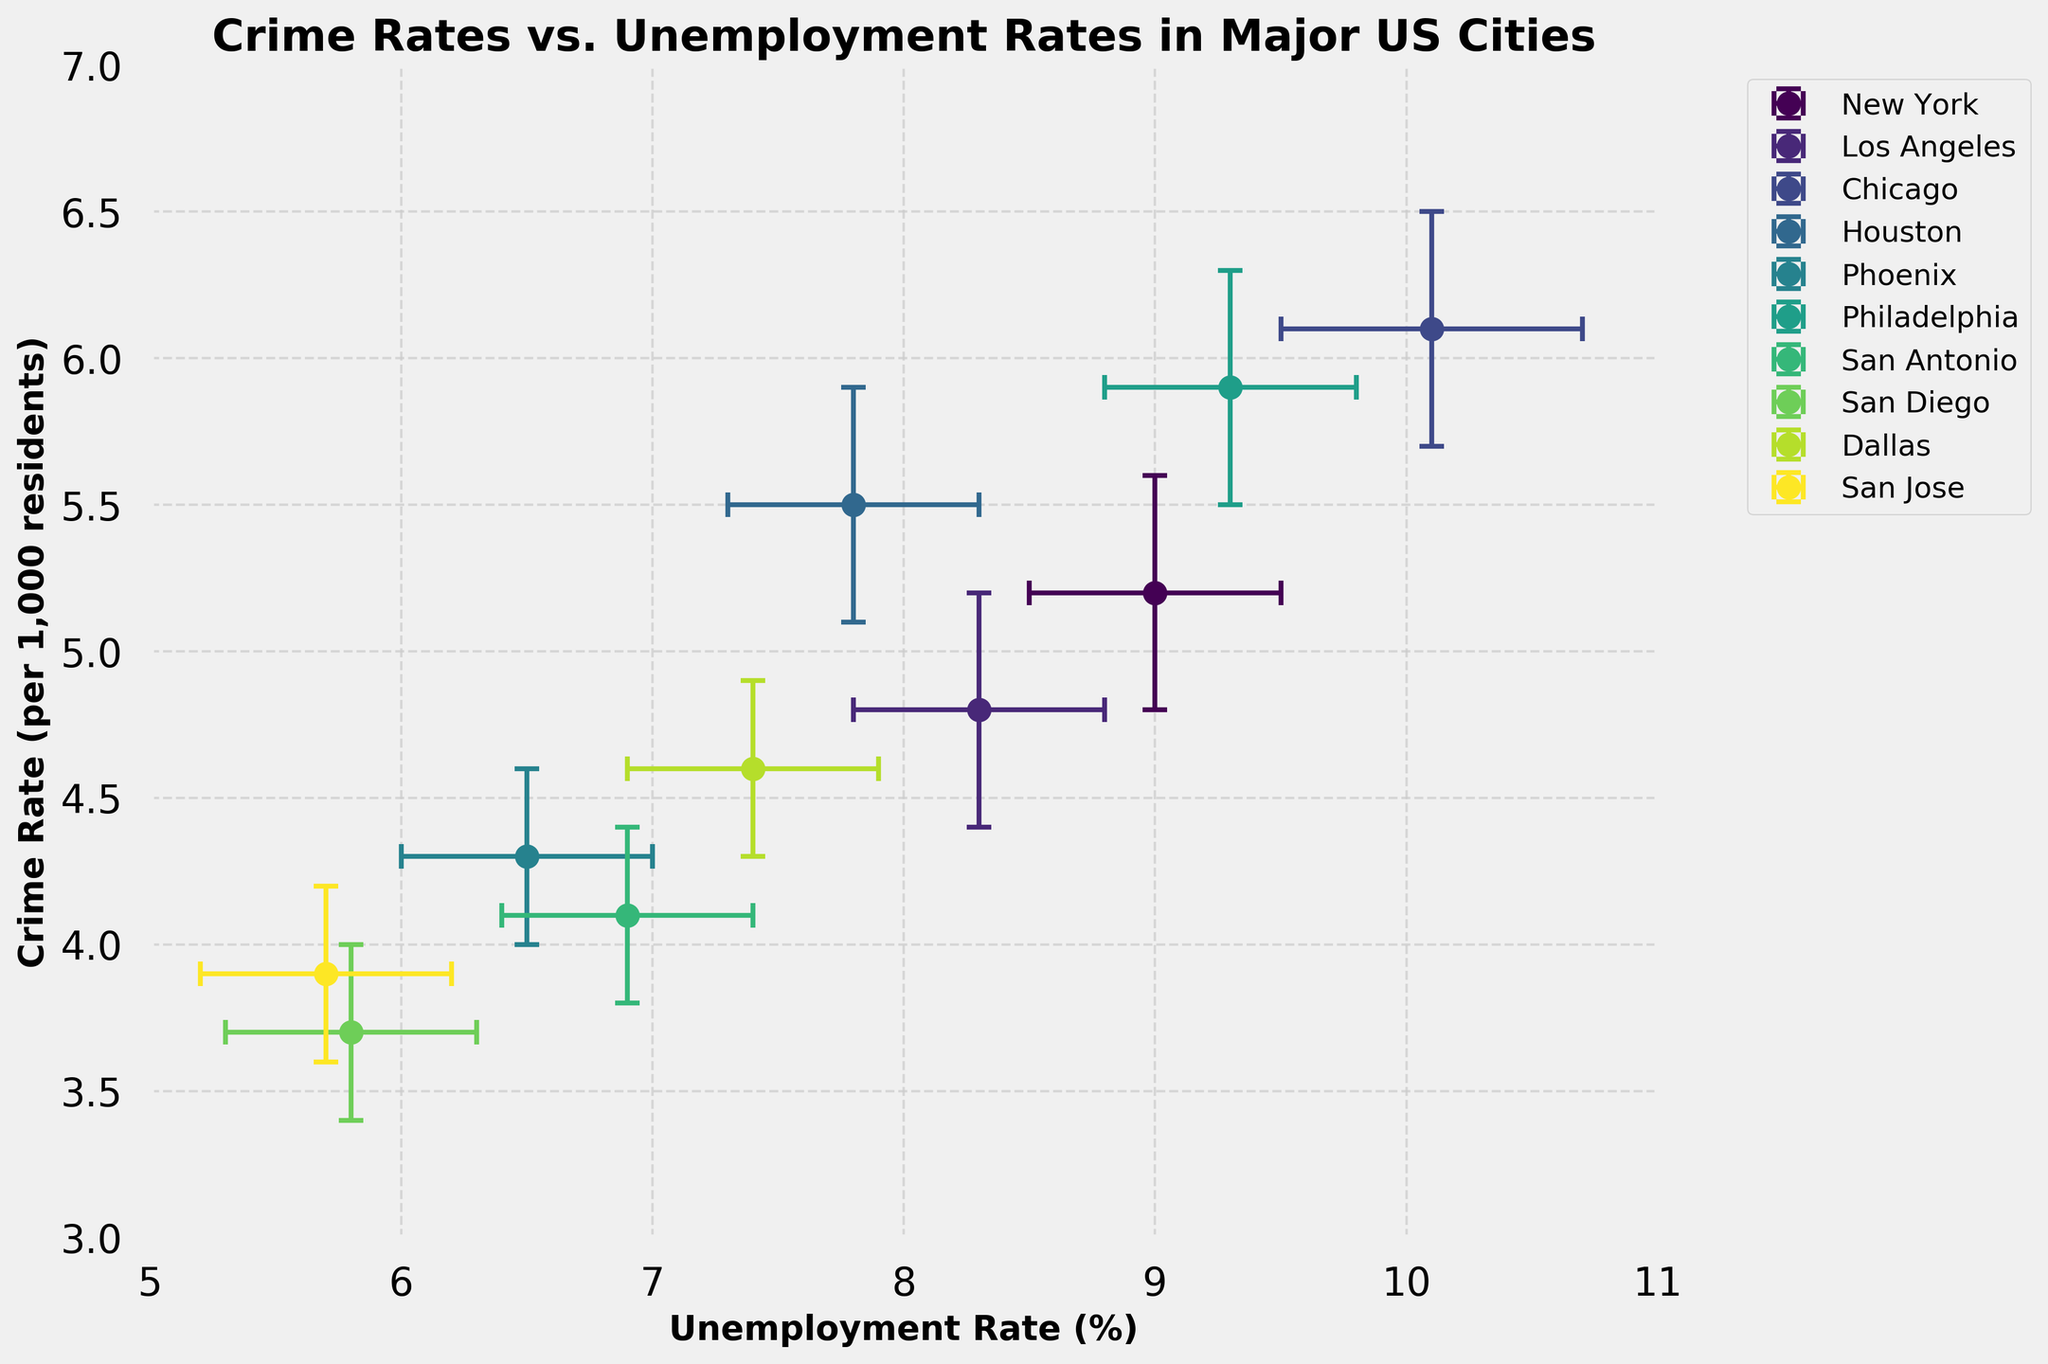What's the title of the plot? The title of the plot is displayed at the top in larger and bold font, specifying the subject of the visualization.
Answer: Crime Rates vs. Unemployment Rates in Major US Cities What's the y-axis label? The y-axis label can be found on the left side of the plot, providing the description of what the y-values represent.
Answer: Crime Rate (per 1,000 residents) Which city has the highest crime rate? The highest crime rate can be identified by finding the data point furthest up on the y-axis.
Answer: Chicago Which city has the lowest unemployment rate? The lowest unemployment rate can be found by locating the data point furthest to the left on the x-axis.
Answer: San Diego What is the unemployment rate of New York? Locate the data point labeled as "New York" and look at its corresponding x-axis value.
Answer: 9.0 How do the confidence intervals for crime rates of Philadelphia and Chicago compare? Examine the error bars that extend vertically from the points representing Philadelphia and Chicago to compare their lengths. Both cities have similar ranges as their CIs overlap each other significantly.
Answer: Similar What range of crime rates does Houston have, based on its confidence interval? Houston's crime rate is displayed on the y-axis with error bars indicating the lower and upper confidence intervals.
Answer: 5.1 to 5.9 per 1,000 residents Which city has both a crime rate under 4.5 and a lower bound for the unemployment rate above 6? Look for data points below 4.5 on the y-axis and above 6 on the lower bound of the errors on the x-axis.
Answer: San Diego How does the crime rate of Dallas compare to the crime rate of Phoenix? Compare the y-values for Dallas and Phoenix to determine which is higher. Dallas's y-value is slightly higher than Phoenix's y-value.
Answer: Dallas's crime rate is higher than Phoenix's What can you infer about the relationship between unemployment and crime rates based on the plot? Observe the overall trend, noting how data points align and whether higher unemployment rates correspond to higher crime rates.
Answer: There's a potential positive relationship between unemployment and crime rates, with some exceptions 